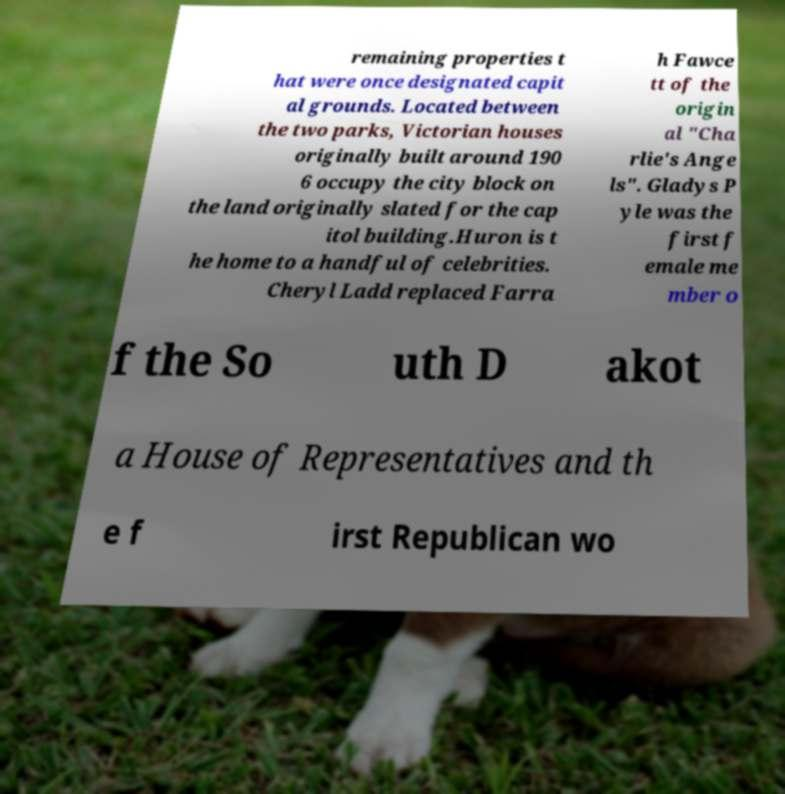Please read and relay the text visible in this image. What does it say? remaining properties t hat were once designated capit al grounds. Located between the two parks, Victorian houses originally built around 190 6 occupy the city block on the land originally slated for the cap itol building.Huron is t he home to a handful of celebrities. Cheryl Ladd replaced Farra h Fawce tt of the origin al "Cha rlie's Ange ls". Gladys P yle was the first f emale me mber o f the So uth D akot a House of Representatives and th e f irst Republican wo 